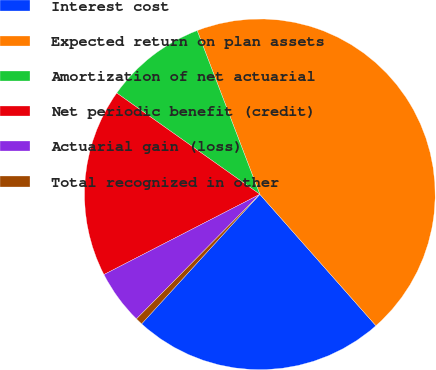Convert chart to OTSL. <chart><loc_0><loc_0><loc_500><loc_500><pie_chart><fcel>Interest cost<fcel>Expected return on plan assets<fcel>Amortization of net actuarial<fcel>Net periodic benefit (credit)<fcel>Actuarial gain (loss)<fcel>Total recognized in other<nl><fcel>23.29%<fcel>44.3%<fcel>9.38%<fcel>17.37%<fcel>5.01%<fcel>0.65%<nl></chart> 